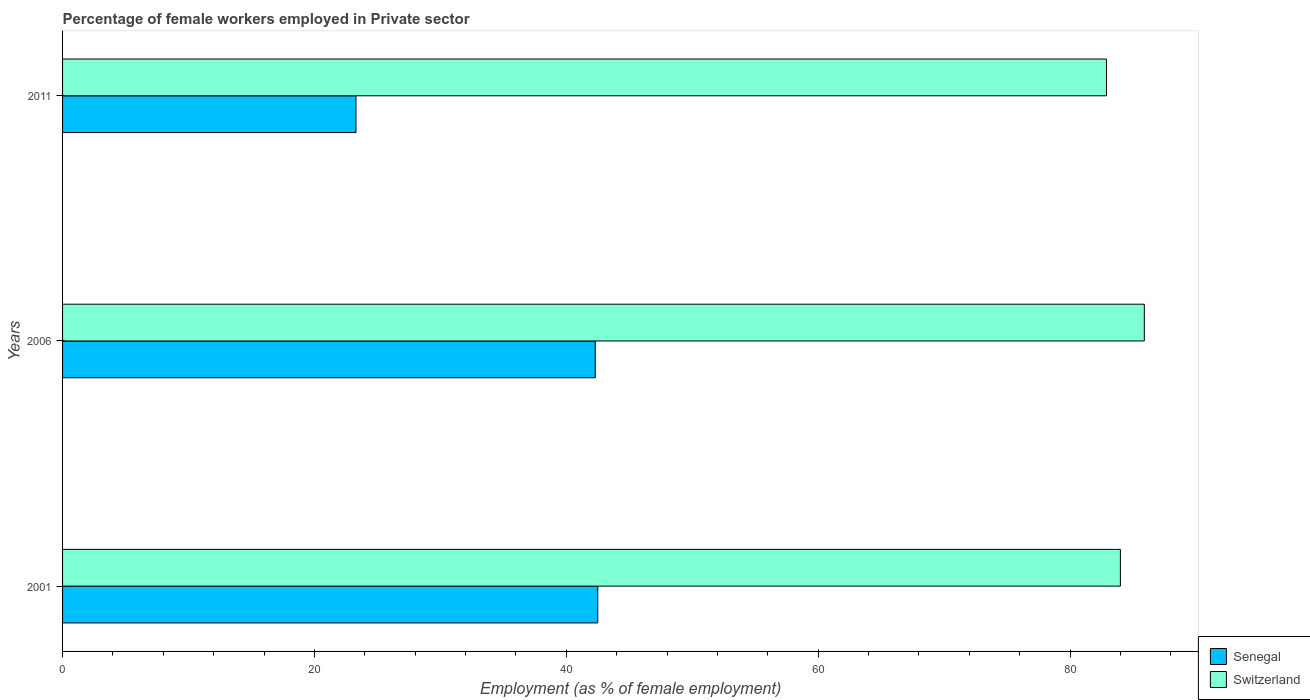How many bars are there on the 3rd tick from the top?
Provide a succinct answer. 2. How many bars are there on the 1st tick from the bottom?
Provide a succinct answer. 2. What is the percentage of females employed in Private sector in Senegal in 2006?
Offer a very short reply. 42.3. Across all years, what is the maximum percentage of females employed in Private sector in Senegal?
Provide a short and direct response. 42.5. Across all years, what is the minimum percentage of females employed in Private sector in Switzerland?
Offer a terse response. 82.9. What is the total percentage of females employed in Private sector in Switzerland in the graph?
Keep it short and to the point. 252.8. What is the difference between the percentage of females employed in Private sector in Senegal in 2001 and that in 2011?
Your answer should be compact. 19.2. What is the difference between the percentage of females employed in Private sector in Switzerland in 2006 and the percentage of females employed in Private sector in Senegal in 2001?
Your answer should be compact. 43.4. What is the average percentage of females employed in Private sector in Senegal per year?
Keep it short and to the point. 36.03. In the year 2006, what is the difference between the percentage of females employed in Private sector in Senegal and percentage of females employed in Private sector in Switzerland?
Make the answer very short. -43.6. What is the ratio of the percentage of females employed in Private sector in Switzerland in 2001 to that in 2011?
Provide a short and direct response. 1.01. Is the difference between the percentage of females employed in Private sector in Senegal in 2006 and 2011 greater than the difference between the percentage of females employed in Private sector in Switzerland in 2006 and 2011?
Offer a very short reply. Yes. What is the difference between the highest and the second highest percentage of females employed in Private sector in Switzerland?
Make the answer very short. 1.9. What is the difference between the highest and the lowest percentage of females employed in Private sector in Switzerland?
Provide a succinct answer. 3. In how many years, is the percentage of females employed in Private sector in Switzerland greater than the average percentage of females employed in Private sector in Switzerland taken over all years?
Provide a succinct answer. 1. Is the sum of the percentage of females employed in Private sector in Switzerland in 2006 and 2011 greater than the maximum percentage of females employed in Private sector in Senegal across all years?
Keep it short and to the point. Yes. What does the 1st bar from the top in 2006 represents?
Your response must be concise. Switzerland. What does the 2nd bar from the bottom in 2001 represents?
Your answer should be very brief. Switzerland. Are all the bars in the graph horizontal?
Provide a short and direct response. Yes. How many years are there in the graph?
Your answer should be very brief. 3. What is the difference between two consecutive major ticks on the X-axis?
Offer a very short reply. 20. Are the values on the major ticks of X-axis written in scientific E-notation?
Your answer should be very brief. No. Does the graph contain any zero values?
Offer a very short reply. No. Does the graph contain grids?
Make the answer very short. No. Where does the legend appear in the graph?
Give a very brief answer. Bottom right. What is the title of the graph?
Your answer should be compact. Percentage of female workers employed in Private sector. What is the label or title of the X-axis?
Give a very brief answer. Employment (as % of female employment). What is the label or title of the Y-axis?
Ensure brevity in your answer.  Years. What is the Employment (as % of female employment) of Senegal in 2001?
Ensure brevity in your answer.  42.5. What is the Employment (as % of female employment) of Switzerland in 2001?
Give a very brief answer. 84. What is the Employment (as % of female employment) of Senegal in 2006?
Your response must be concise. 42.3. What is the Employment (as % of female employment) in Switzerland in 2006?
Offer a very short reply. 85.9. What is the Employment (as % of female employment) in Senegal in 2011?
Make the answer very short. 23.3. What is the Employment (as % of female employment) in Switzerland in 2011?
Provide a succinct answer. 82.9. Across all years, what is the maximum Employment (as % of female employment) in Senegal?
Keep it short and to the point. 42.5. Across all years, what is the maximum Employment (as % of female employment) of Switzerland?
Make the answer very short. 85.9. Across all years, what is the minimum Employment (as % of female employment) in Senegal?
Ensure brevity in your answer.  23.3. Across all years, what is the minimum Employment (as % of female employment) in Switzerland?
Your answer should be very brief. 82.9. What is the total Employment (as % of female employment) in Senegal in the graph?
Offer a terse response. 108.1. What is the total Employment (as % of female employment) of Switzerland in the graph?
Your answer should be compact. 252.8. What is the difference between the Employment (as % of female employment) in Senegal in 2001 and that in 2006?
Keep it short and to the point. 0.2. What is the difference between the Employment (as % of female employment) of Switzerland in 2001 and that in 2011?
Keep it short and to the point. 1.1. What is the difference between the Employment (as % of female employment) in Senegal in 2001 and the Employment (as % of female employment) in Switzerland in 2006?
Keep it short and to the point. -43.4. What is the difference between the Employment (as % of female employment) in Senegal in 2001 and the Employment (as % of female employment) in Switzerland in 2011?
Provide a short and direct response. -40.4. What is the difference between the Employment (as % of female employment) in Senegal in 2006 and the Employment (as % of female employment) in Switzerland in 2011?
Your response must be concise. -40.6. What is the average Employment (as % of female employment) in Senegal per year?
Provide a short and direct response. 36.03. What is the average Employment (as % of female employment) in Switzerland per year?
Provide a short and direct response. 84.27. In the year 2001, what is the difference between the Employment (as % of female employment) of Senegal and Employment (as % of female employment) of Switzerland?
Give a very brief answer. -41.5. In the year 2006, what is the difference between the Employment (as % of female employment) of Senegal and Employment (as % of female employment) of Switzerland?
Provide a short and direct response. -43.6. In the year 2011, what is the difference between the Employment (as % of female employment) in Senegal and Employment (as % of female employment) in Switzerland?
Your answer should be very brief. -59.6. What is the ratio of the Employment (as % of female employment) in Senegal in 2001 to that in 2006?
Offer a terse response. 1. What is the ratio of the Employment (as % of female employment) in Switzerland in 2001 to that in 2006?
Ensure brevity in your answer.  0.98. What is the ratio of the Employment (as % of female employment) in Senegal in 2001 to that in 2011?
Your answer should be very brief. 1.82. What is the ratio of the Employment (as % of female employment) of Switzerland in 2001 to that in 2011?
Offer a very short reply. 1.01. What is the ratio of the Employment (as % of female employment) of Senegal in 2006 to that in 2011?
Keep it short and to the point. 1.82. What is the ratio of the Employment (as % of female employment) of Switzerland in 2006 to that in 2011?
Offer a terse response. 1.04. What is the difference between the highest and the lowest Employment (as % of female employment) of Senegal?
Your response must be concise. 19.2. 